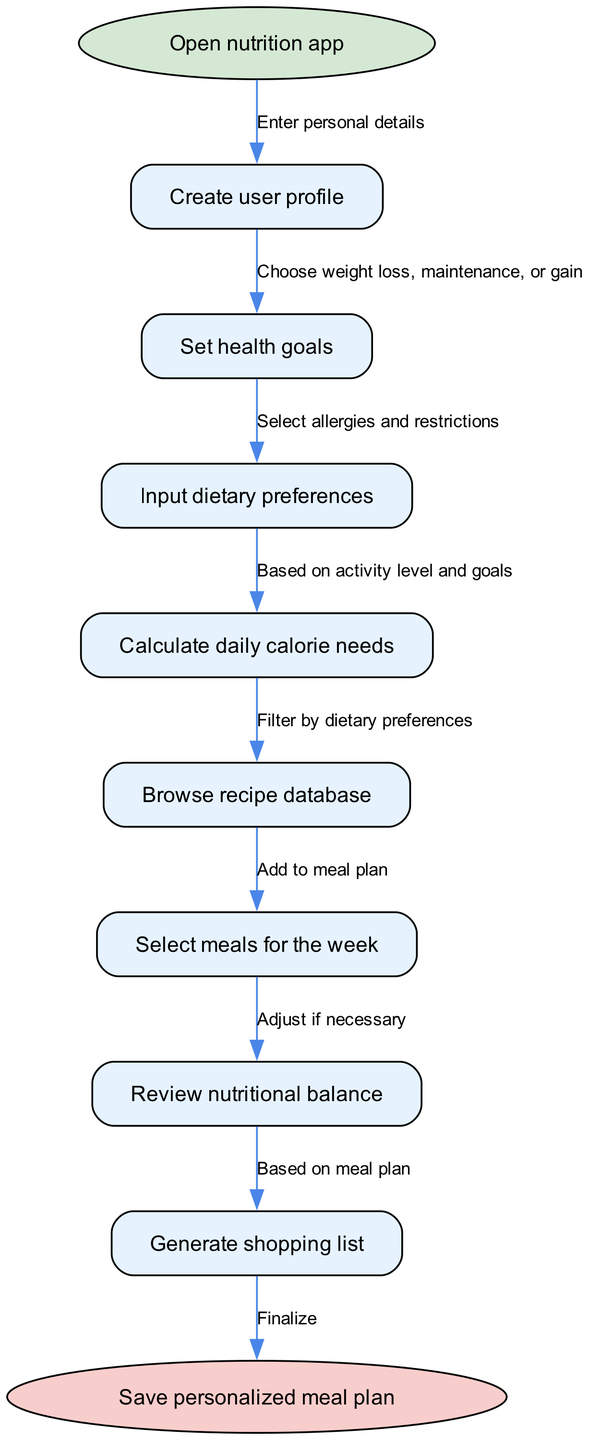What is the first step in the process? The first step is indicated by the start node, which states "Open nutrition app." This is the initial action a user must take to begin creating a personalized meal plan.
Answer: Open nutrition app How many steps are included in the flow chart? By counting the individual steps listed between the start and end nodes, there are a total of eight distinct steps.
Answer: 8 What dietary preferences can you input in the meal planning process? The step specifically mentions "Select allergies and restrictions," indicating the kinds of dietary preferences the user can specify.
Answer: Allergies and restrictions What happens after calculating daily calorie needs? The next step indicates that after calculating daily calorie needs, the user moves on to "Browse recipe database," revealing the flow of actions following that calculation.
Answer: Browse recipe database What must a user do before they can generate a shopping list? The diagram shows that a user must first "Select meals for the week" before they can proceed to the step of "Generate shopping list." This indicates a sequence where meal selection is necessary for list generation.
Answer: Select meals for the week What is the final step in creating a personalized meal plan? The final step, marked at the end node, states "Save personalized meal plan," which is the concluding action that consolidates all prior steps into a finalized plan.
Answer: Save personalized meal plan How does one enter personal details? The diagram shows that entering personal details is part of the "Create user profile" step, where users need to provide relevant information about themselves.
Answer: Create user profile Can the user adjust the nutritional balance of the meal plan? Yes, the flow includes a step labeled "Review nutritional balance," which indicates that users have the option to make necessary adjustments before finalizing their meal plans.
Answer: Yes 